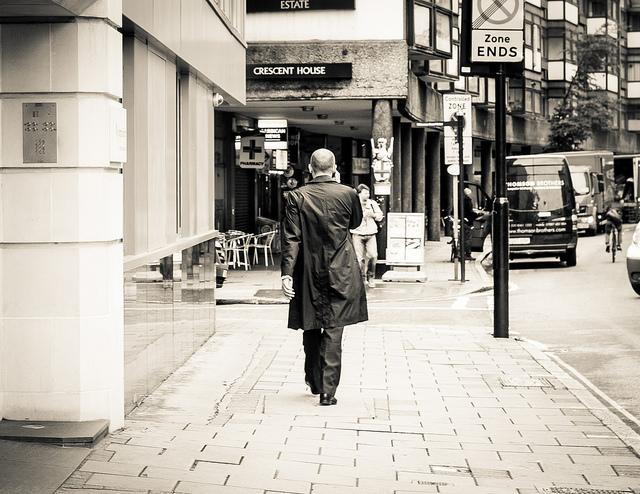During what time of day are the pedestrians walking on this sidewalk? afternoon 